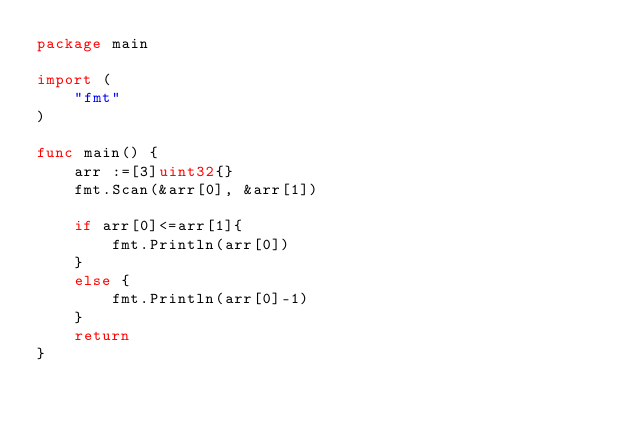<code> <loc_0><loc_0><loc_500><loc_500><_Go_>package main

import (
    "fmt"
)

func main() {
    arr :=[3]uint32{}
    fmt.Scan(&arr[0], &arr[1])

	if arr[0]<=arr[1]{
		fmt.Println(arr[0])
	}
	else {
		fmt.Println(arr[0]-1)
	}
	return
}</code> 